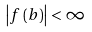<formula> <loc_0><loc_0><loc_500><loc_500>\left | f \left ( b \right ) \right | < \infty</formula> 